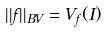<formula> <loc_0><loc_0><loc_500><loc_500>| | f | | _ { B V } = V _ { f } ( I )</formula> 